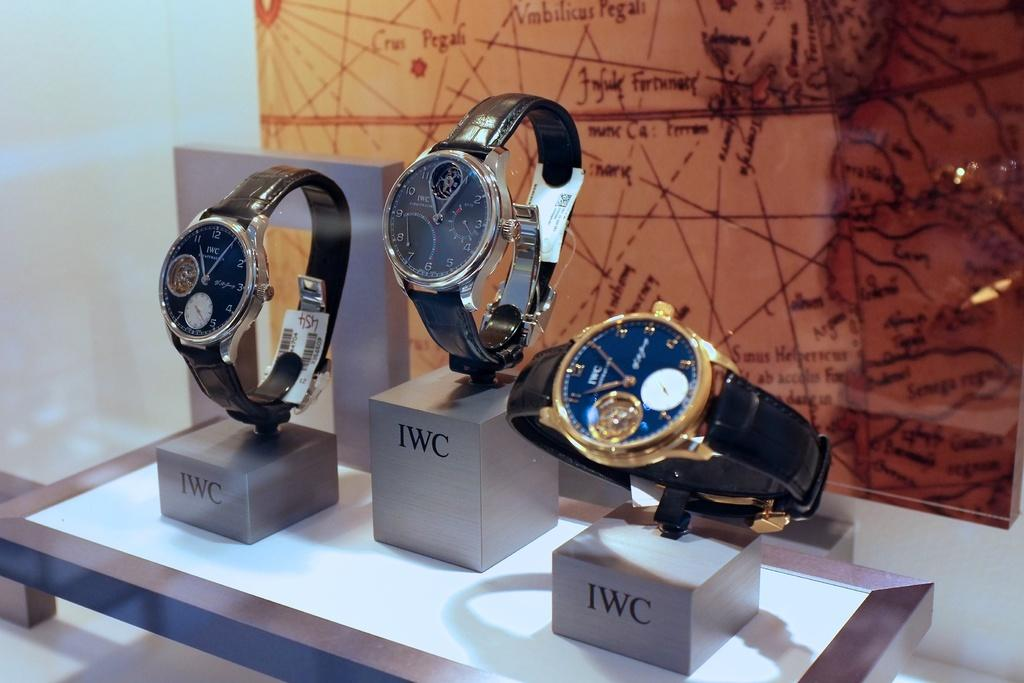<image>
Offer a succinct explanation of the picture presented. Three watches that are labeled IWC in front of a map. 